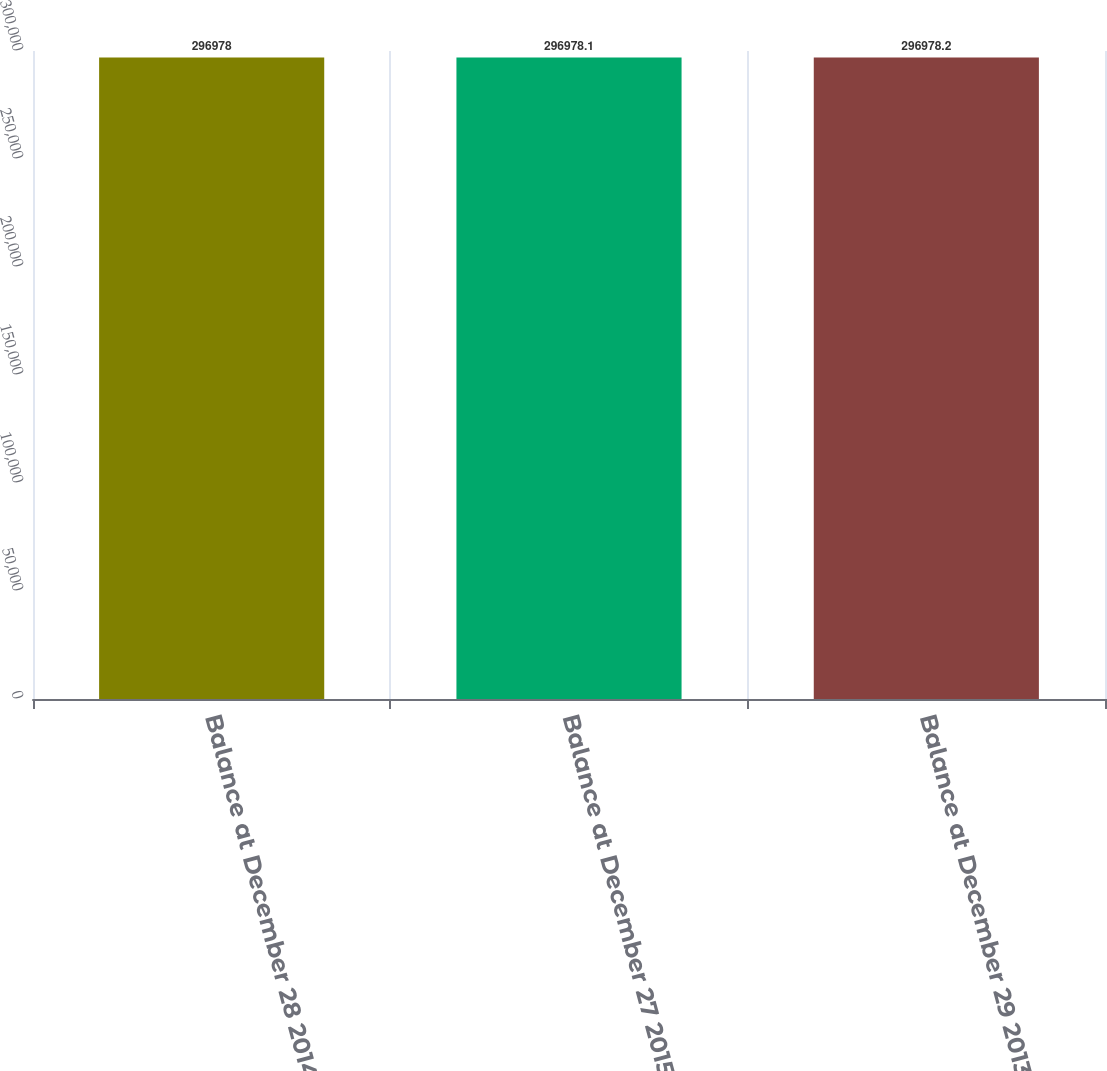<chart> <loc_0><loc_0><loc_500><loc_500><bar_chart><fcel>Balance at December 28 2014<fcel>Balance at December 27 2015<fcel>Balance at December 29 2013<nl><fcel>296978<fcel>296978<fcel>296978<nl></chart> 